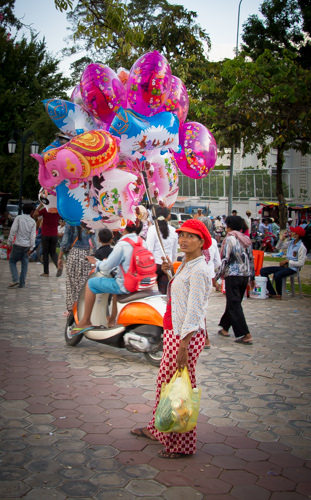<image>
Can you confirm if the fence is behind the man? Yes. From this viewpoint, the fence is positioned behind the man, with the man partially or fully occluding the fence. Is the balloons behind the woman? Yes. From this viewpoint, the balloons is positioned behind the woman, with the woman partially or fully occluding the balloons. 